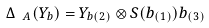Convert formula to latex. <formula><loc_0><loc_0><loc_500><loc_500>\Delta _ { \ A } ( Y _ { b } ) = Y _ { b ( 2 ) } \otimes S ( b _ { ( 1 ) } ) b _ { ( 3 ) }</formula> 